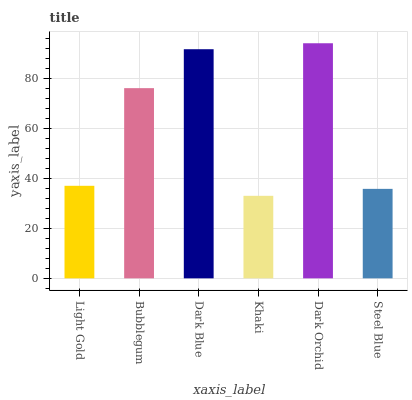Is Khaki the minimum?
Answer yes or no. Yes. Is Dark Orchid the maximum?
Answer yes or no. Yes. Is Bubblegum the minimum?
Answer yes or no. No. Is Bubblegum the maximum?
Answer yes or no. No. Is Bubblegum greater than Light Gold?
Answer yes or no. Yes. Is Light Gold less than Bubblegum?
Answer yes or no. Yes. Is Light Gold greater than Bubblegum?
Answer yes or no. No. Is Bubblegum less than Light Gold?
Answer yes or no. No. Is Bubblegum the high median?
Answer yes or no. Yes. Is Light Gold the low median?
Answer yes or no. Yes. Is Dark Orchid the high median?
Answer yes or no. No. Is Steel Blue the low median?
Answer yes or no. No. 